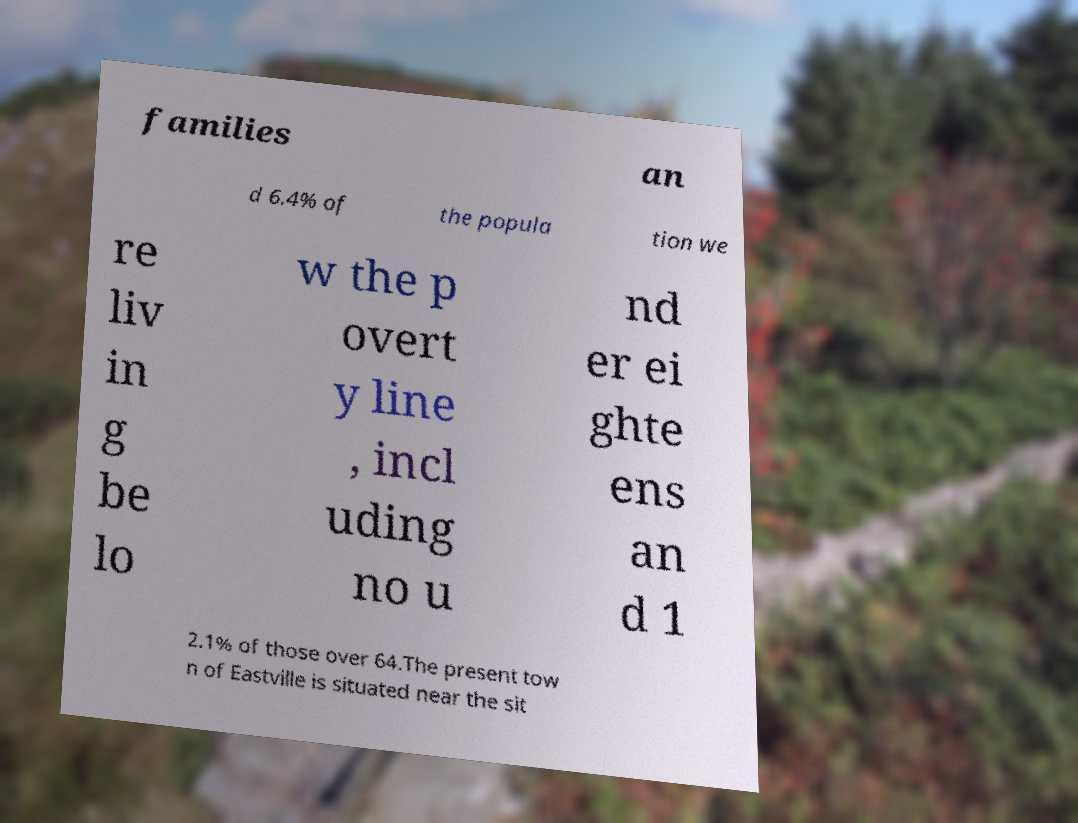There's text embedded in this image that I need extracted. Can you transcribe it verbatim? families an d 6.4% of the popula tion we re liv in g be lo w the p overt y line , incl uding no u nd er ei ghte ens an d 1 2.1% of those over 64.The present tow n of Eastville is situated near the sit 